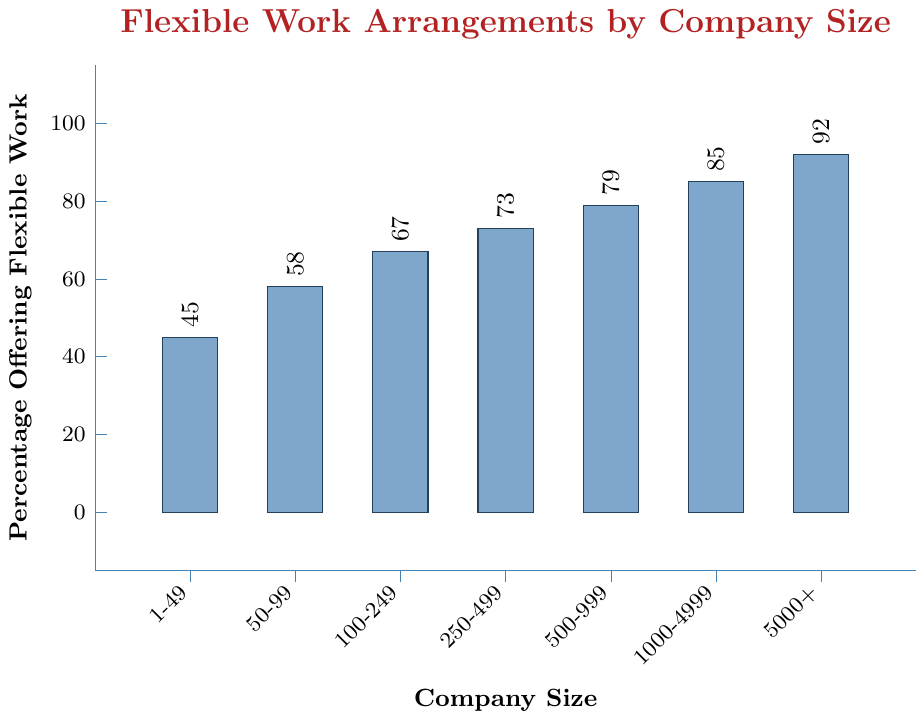What percentage of companies with 250-499 employees offer flexible work arrangements? Look at the bar corresponding to the category '250-499 employees'. The height of the bar indicates the percentage. The percentage is marked at the top of the bar.
Answer: 73% How much higher is the percentage of companies offering flexible work for those with 1000-4999 employees compared to those with 1-49 employees? Find the percentage for both the '1000-4999' and '1-49' employee categories. Subtract the latter from the former, (85 - 45 = 40).
Answer: 40% Calculate the average percentage of companies offering flexible work arrangements for companies with less than 1000 employees. Add up the percentages for companies with less than 1000 employees: (45 + 58 + 67 + 73 + 79). Divide the sum by the number of categories: (45 + 58 + 67 + 73 + 79) / 5 = 322 / 5 = 64.4.
Answer: 64.4% Which company size category has the lowest percentage of companies offering flexible work arrangements? Identify the bar with the smallest height and read the label. The '1-49 employees' category has the lowest percentage.
Answer: 1-49 employees Compare the percentage of companies offering flexible work between those with 500-999 employees and 5000+ employees. Which is greater and by how much? Look at the bars for the '500-999' and '5000+' categories. Subtract the former's percentage from the latter's percentage, (92 - 79 = 13). The percentage for '5000+' employees is greater by 13 percentage points.
Answer: 5000+ employees, by 13% What is the median percentage of companies offering flexible work arrangements across all company sizes? List the percentages (45, 58, 67, 73, 79, 85, 92), since there is an odd number of values, the median is the middle value, which is 73.
Answer: 73% What is the range of percentages for companies offering flexible work arrangements? Subtract the smallest percentage (45) from the largest percentage (92), 92 - 45 = 47.
Answer: 47% Is the percentage of companies offering flexible work arrangements greater for companies with 100-249 employees or for those with 50-99 employees, and by how much? Compare the percentages for '100-249' (67) and '50-99' (58). Subtract the percentage for '50-99' employees from that for '100-249' employees, 67 - 58 = 9. The '100-249 employees' category is greater by 9 percentage points.
Answer: 100-249 employees, by 9% Which company size category has a percentage offering flexible work arrangements closest to 50%? Compare the percentage values to 50%. The '50-99 employees' category, which has 58%, is the closest.
Answer: 50-99 employees 